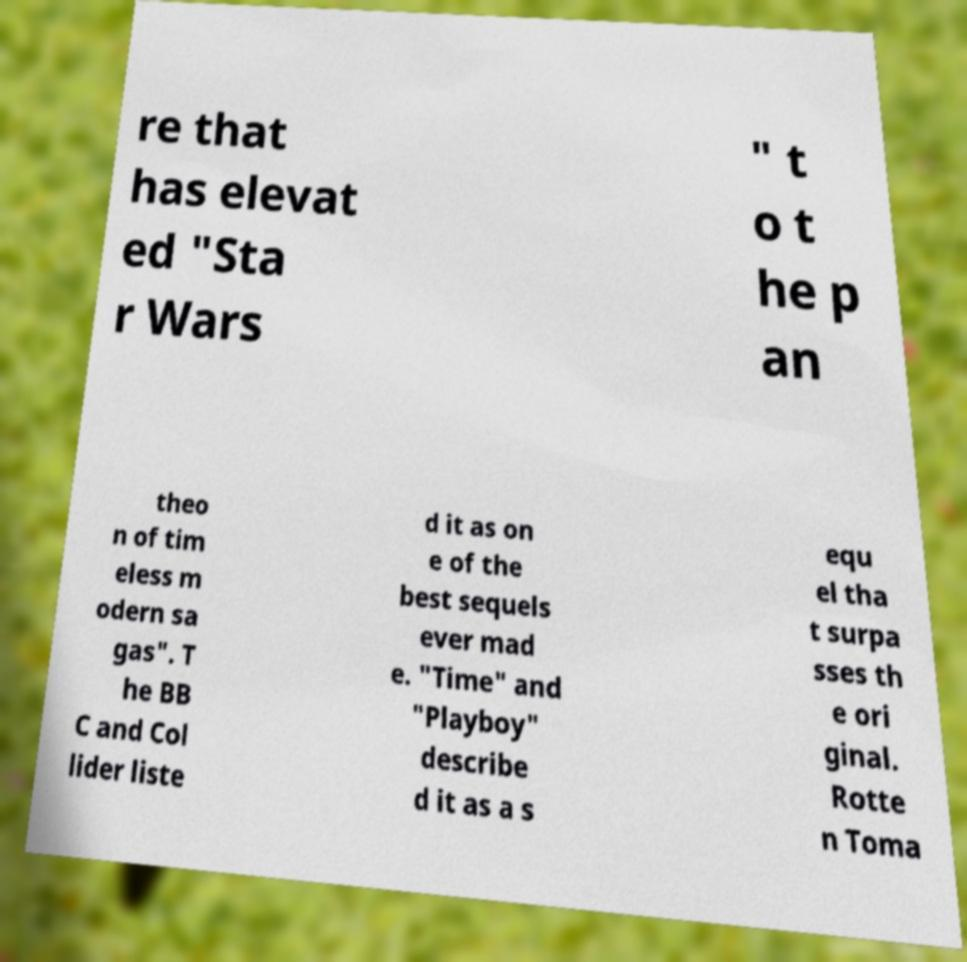Could you extract and type out the text from this image? re that has elevat ed "Sta r Wars " t o t he p an theo n of tim eless m odern sa gas". T he BB C and Col lider liste d it as on e of the best sequels ever mad e. "Time" and "Playboy" describe d it as a s equ el tha t surpa sses th e ori ginal. Rotte n Toma 